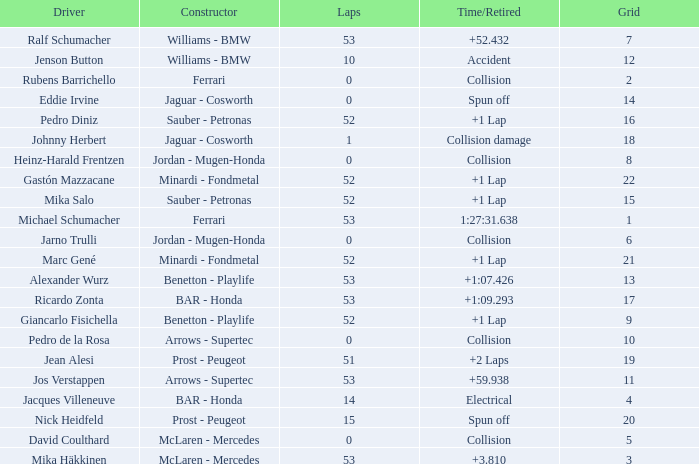What is the average Laps for a grid smaller than 17, and a Constructor of williams - bmw, driven by jenson button? 10.0. 